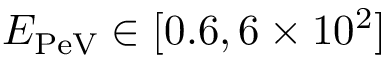<formula> <loc_0><loc_0><loc_500><loc_500>E _ { P e V } \in [ 0 . 6 , 6 \times 1 0 ^ { 2 } ]</formula> 